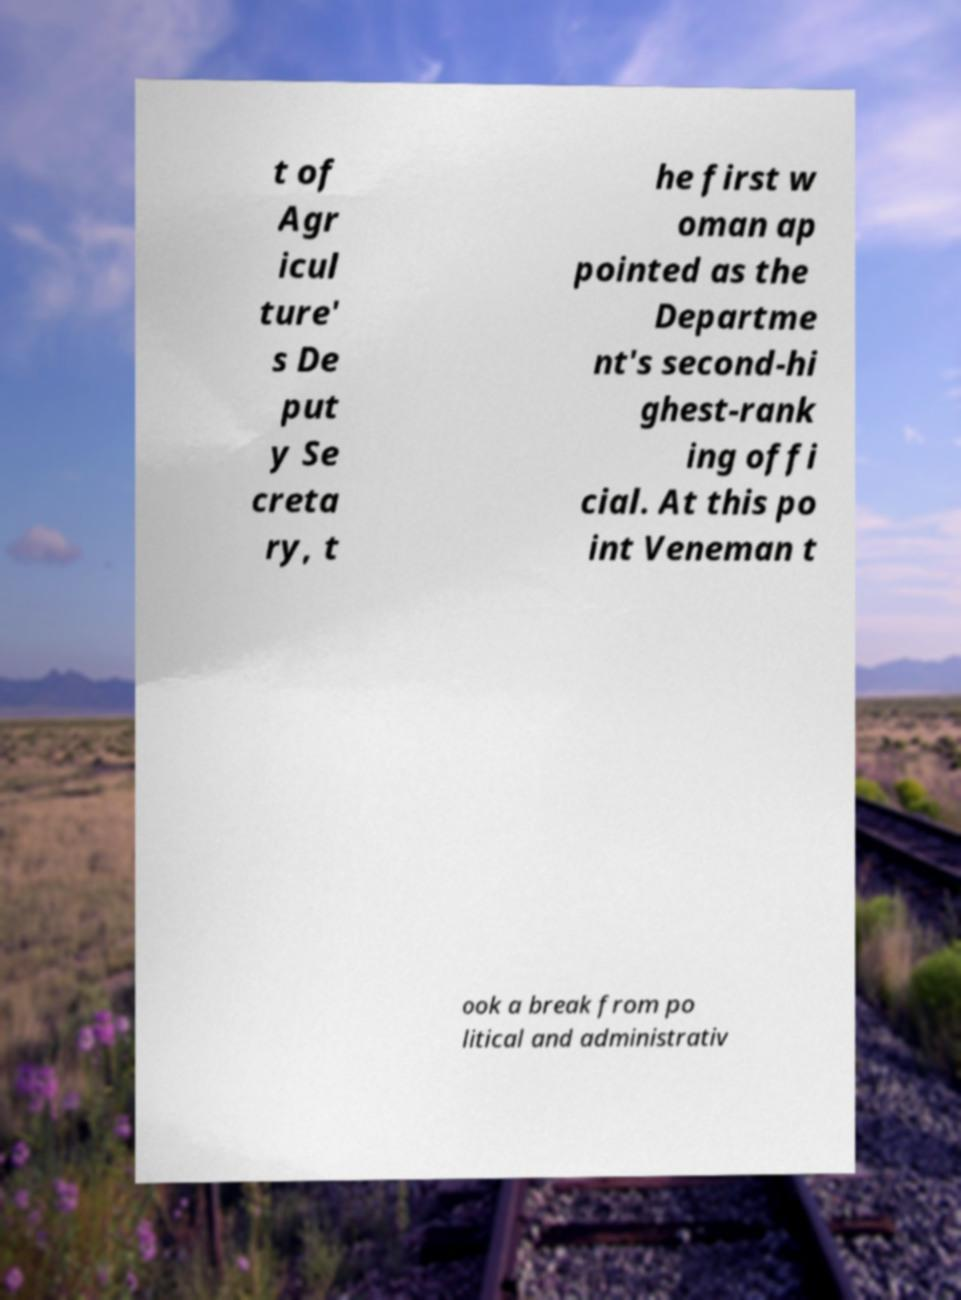Could you extract and type out the text from this image? t of Agr icul ture' s De put y Se creta ry, t he first w oman ap pointed as the Departme nt's second-hi ghest-rank ing offi cial. At this po int Veneman t ook a break from po litical and administrativ 